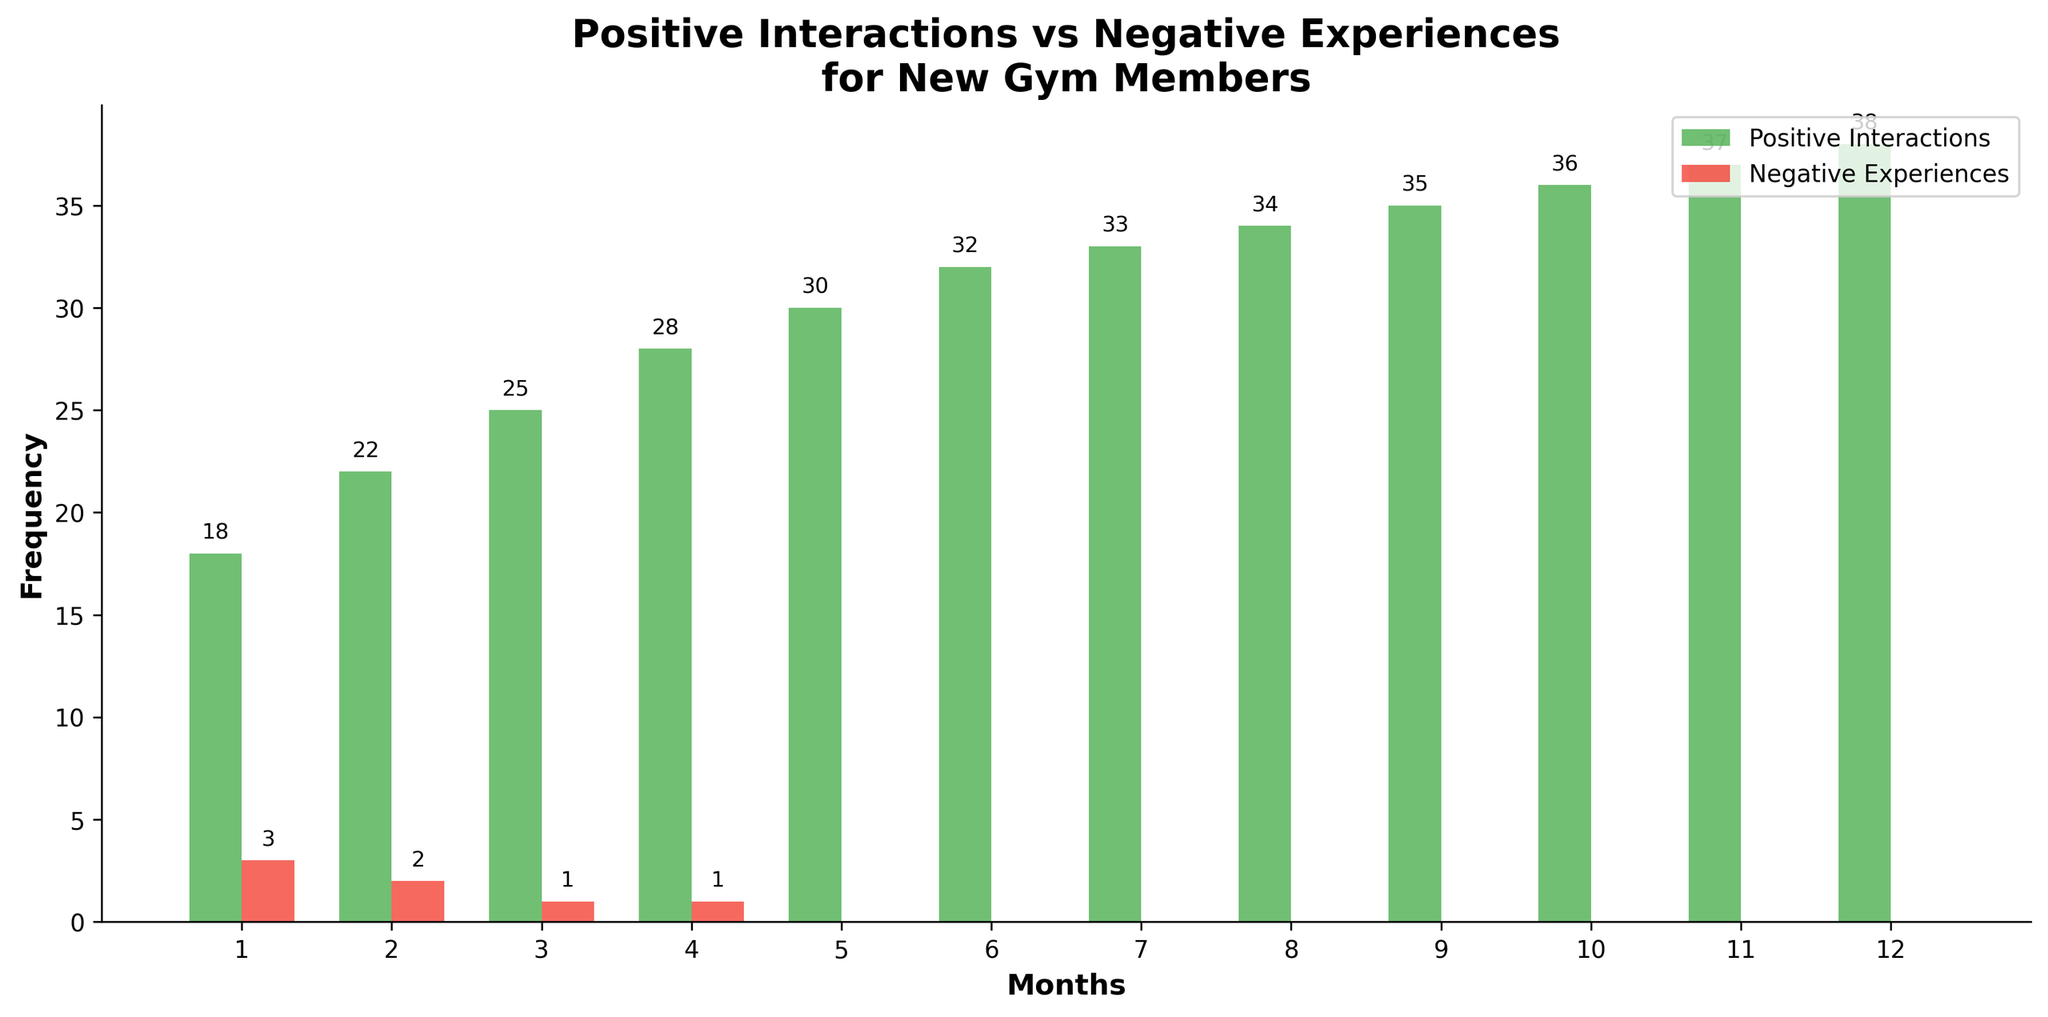What is the total number of positive interactions reported in the last three months of the year? To find the total number of positive interactions in the last three months, sum the values for months 10, 11, and 12: 36 + 37 + 38 = 111
Answer: 111 In which month was there the highest number of negative experiences reported? Observing the red bars representing negative experiences, the highest count is in month 1 with a value of 3.
Answer: Month 1 How did the frequency of negative experiences change from month 1 to month 3? The frequency of negative experiences in month 1 is 3, in month 2 it is 2, and in month 3 it is 1. Hence, it consistently decreased each month.
Answer: Decreased By how much did positive interactions increase from month 1 to month 12? Positive interactions in month 1 is 18 and in month 12 it is 38. The increase is calculated as 38 - 18 = 20.
Answer: 20 Which has a higher value in month 5: the positive interactions or negative experiences? In month 5, the green bar representing positive interactions has a value of 30, while the red bar representing negative experiences has a value of 0. Hence, positive interactions are higher.
Answer: Positive interactions What is the average number of positive interactions reported over the first six months? The values for the first six months are 18, 22, 25, 28, 30, and 32. Summing these gives 155. The average is then 155 / 6 ≈ 25.83.
Answer: 25.83 By what percentage did positive interactions increase from month 1 to month 6? Positive interactions in month 1 are 18 and in month 6 are 32. The increase is 32 - 18 = 14. The percentage increase is (14 / 18) * 100 ≈ 77.78%.
Answer: 77.78% What do the colors green and red represent in the chart? The green bars represent positive interactions, while the red bars represent negative experiences.
Answer: Positive interactions and negative experiences Is there any month where negative experiences are equal to zero? If yes, list them. Observing the red bars, months 5 through 12 all show a value of zero for negative experiences.
Answer: Months 5, 6, 7, 8, 9, 10, 11, 12 In which month did the positive interactions surpass 30 for the first time? Observing the green bars, the positive interactions first surpass 30 in month 6 with a value of 32.
Answer: Month 6 